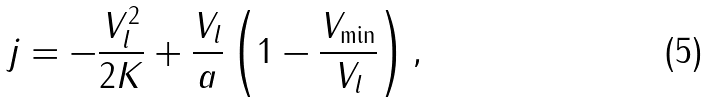Convert formula to latex. <formula><loc_0><loc_0><loc_500><loc_500>j = - \frac { V _ { l } ^ { 2 } } { 2 K } + \frac { V _ { l } } { a } \left ( 1 - \frac { V _ { \min } } { V _ { l } } \right ) ,</formula> 